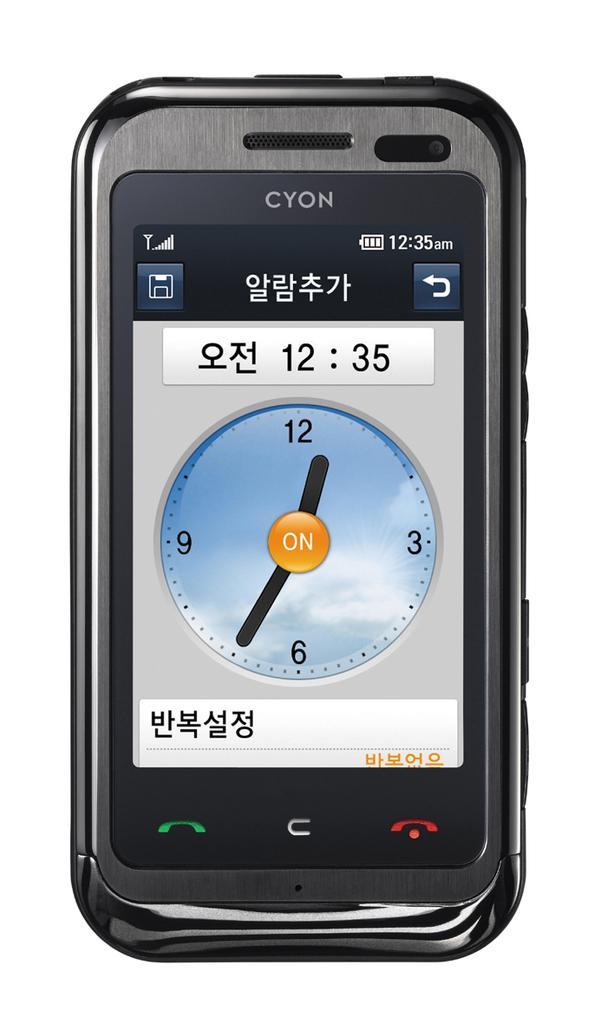<image>
Relay a brief, clear account of the picture shown. the cyon phone is open to the time and date screen 